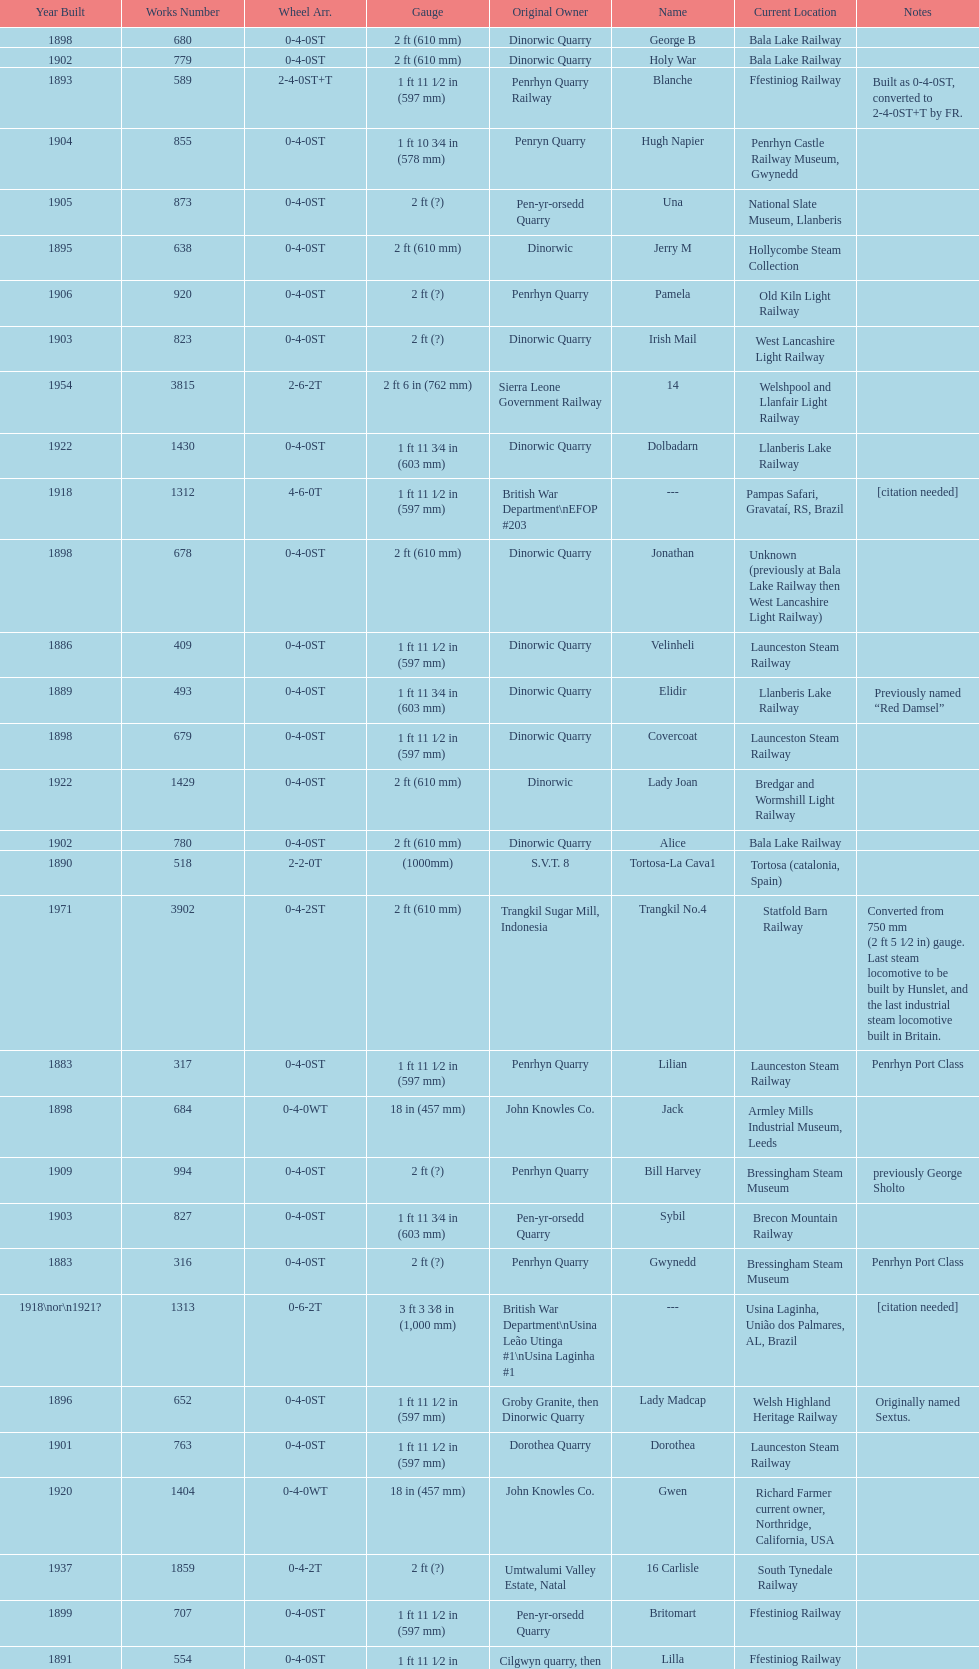What is the difference in gauge between works numbers 541 and 542? 32 mm. Help me parse the entirety of this table. {'header': ['Year Built', 'Works Number', 'Wheel Arr.', 'Gauge', 'Original Owner', 'Name', 'Current Location', 'Notes'], 'rows': [['1898', '680', '0-4-0ST', '2\xa0ft (610\xa0mm)', 'Dinorwic Quarry', 'George B', 'Bala Lake Railway', ''], ['1902', '779', '0-4-0ST', '2\xa0ft (610\xa0mm)', 'Dinorwic Quarry', 'Holy War', 'Bala Lake Railway', ''], ['1893', '589', '2-4-0ST+T', '1\xa0ft 11\xa01⁄2\xa0in (597\xa0mm)', 'Penrhyn Quarry Railway', 'Blanche', 'Ffestiniog Railway', 'Built as 0-4-0ST, converted to 2-4-0ST+T by FR.'], ['1904', '855', '0-4-0ST', '1\xa0ft 10\xa03⁄4\xa0in (578\xa0mm)', 'Penryn Quarry', 'Hugh Napier', 'Penrhyn Castle Railway Museum, Gwynedd', ''], ['1905', '873', '0-4-0ST', '2\xa0ft (?)', 'Pen-yr-orsedd Quarry', 'Una', 'National Slate Museum, Llanberis', ''], ['1895', '638', '0-4-0ST', '2\xa0ft (610\xa0mm)', 'Dinorwic', 'Jerry M', 'Hollycombe Steam Collection', ''], ['1906', '920', '0-4-0ST', '2\xa0ft (?)', 'Penrhyn Quarry', 'Pamela', 'Old Kiln Light Railway', ''], ['1903', '823', '0-4-0ST', '2\xa0ft (?)', 'Dinorwic Quarry', 'Irish Mail', 'West Lancashire Light Railway', ''], ['1954', '3815', '2-6-2T', '2\xa0ft 6\xa0in (762\xa0mm)', 'Sierra Leone Government Railway', '14', 'Welshpool and Llanfair Light Railway', ''], ['1922', '1430', '0-4-0ST', '1\xa0ft 11\xa03⁄4\xa0in (603\xa0mm)', 'Dinorwic Quarry', 'Dolbadarn', 'Llanberis Lake Railway', ''], ['1918', '1312', '4-6-0T', '1\xa0ft\xa011\xa01⁄2\xa0in (597\xa0mm)', 'British War Department\\nEFOP #203', '---', 'Pampas Safari, Gravataí, RS, Brazil', '[citation needed]'], ['1898', '678', '0-4-0ST', '2\xa0ft (610\xa0mm)', 'Dinorwic Quarry', 'Jonathan', 'Unknown (previously at Bala Lake Railway then West Lancashire Light Railway)', ''], ['1886', '409', '0-4-0ST', '1\xa0ft 11\xa01⁄2\xa0in (597\xa0mm)', 'Dinorwic Quarry', 'Velinheli', 'Launceston Steam Railway', ''], ['1889', '493', '0-4-0ST', '1\xa0ft 11\xa03⁄4\xa0in (603\xa0mm)', 'Dinorwic Quarry', 'Elidir', 'Llanberis Lake Railway', 'Previously named “Red Damsel”'], ['1898', '679', '0-4-0ST', '1\xa0ft 11\xa01⁄2\xa0in (597\xa0mm)', 'Dinorwic Quarry', 'Covercoat', 'Launceston Steam Railway', ''], ['1922', '1429', '0-4-0ST', '2\xa0ft (610\xa0mm)', 'Dinorwic', 'Lady Joan', 'Bredgar and Wormshill Light Railway', ''], ['1902', '780', '0-4-0ST', '2\xa0ft (610\xa0mm)', 'Dinorwic Quarry', 'Alice', 'Bala Lake Railway', ''], ['1890', '518', '2-2-0T', '(1000mm)', 'S.V.T. 8', 'Tortosa-La Cava1', 'Tortosa (catalonia, Spain)', ''], ['1971', '3902', '0-4-2ST', '2\xa0ft (610\xa0mm)', 'Trangkil Sugar Mill, Indonesia', 'Trangkil No.4', 'Statfold Barn Railway', 'Converted from 750\xa0mm (2\xa0ft\xa05\xa01⁄2\xa0in) gauge. Last steam locomotive to be built by Hunslet, and the last industrial steam locomotive built in Britain.'], ['1883', '317', '0-4-0ST', '1\xa0ft 11\xa01⁄2\xa0in (597\xa0mm)', 'Penrhyn Quarry', 'Lilian', 'Launceston Steam Railway', 'Penrhyn Port Class'], ['1898', '684', '0-4-0WT', '18\xa0in (457\xa0mm)', 'John Knowles Co.', 'Jack', 'Armley Mills Industrial Museum, Leeds', ''], ['1909', '994', '0-4-0ST', '2\xa0ft (?)', 'Penrhyn Quarry', 'Bill Harvey', 'Bressingham Steam Museum', 'previously George Sholto'], ['1903', '827', '0-4-0ST', '1\xa0ft 11\xa03⁄4\xa0in (603\xa0mm)', 'Pen-yr-orsedd Quarry', 'Sybil', 'Brecon Mountain Railway', ''], ['1883', '316', '0-4-0ST', '2\xa0ft (?)', 'Penrhyn Quarry', 'Gwynedd', 'Bressingham Steam Museum', 'Penrhyn Port Class'], ['1918\\nor\\n1921?', '1313', '0-6-2T', '3\xa0ft\xa03\xa03⁄8\xa0in (1,000\xa0mm)', 'British War Department\\nUsina Leão Utinga #1\\nUsina Laginha #1', '---', 'Usina Laginha, União dos Palmares, AL, Brazil', '[citation needed]'], ['1896', '652', '0-4-0ST', '1\xa0ft 11\xa01⁄2\xa0in (597\xa0mm)', 'Groby Granite, then Dinorwic Quarry', 'Lady Madcap', 'Welsh Highland Heritage Railway', 'Originally named Sextus.'], ['1901', '763', '0-4-0ST', '1\xa0ft 11\xa01⁄2\xa0in (597\xa0mm)', 'Dorothea Quarry', 'Dorothea', 'Launceston Steam Railway', ''], ['1920', '1404', '0-4-0WT', '18\xa0in (457\xa0mm)', 'John Knowles Co.', 'Gwen', 'Richard Farmer current owner, Northridge, California, USA', ''], ['1937', '1859', '0-4-2T', '2\xa0ft (?)', 'Umtwalumi Valley Estate, Natal', '16 Carlisle', 'South Tynedale Railway', ''], ['1899', '707', '0-4-0ST', '1\xa0ft 11\xa01⁄2\xa0in (597\xa0mm)', 'Pen-yr-orsedd Quarry', 'Britomart', 'Ffestiniog Railway', ''], ['1891', '554', '0-4-0ST', '1\xa0ft 11\xa01⁄2\xa0in (597\xa0mm)', 'Cilgwyn quarry, then Penrhyn Quarry Railway', 'Lilla', 'Ffestiniog Railway', ''], ['1882', '283', '0-4-0ST', '1\xa0ft 10\xa03⁄4\xa0in (578\xa0mm)', 'Penrhyn Quarry', 'Charles', 'Penrhyn Castle Railway Museum', ''], ['1903', '822', '0-4-0ST', '2\xa0ft (610\xa0mm)', 'Dinorwic Quarry', 'Maid Marian', 'Bala Lake Railway', ''], ['1893', '590', '2-4-0ST+T', '1\xa0ft 11\xa01⁄2\xa0in (597\xa0mm)', 'Penrhyn Quarry Railway', 'Linda', 'Ffestiniog Railway', 'Built as 0-4-0ST, converted to 2-4-0ST+T by FR.'], ['1902', '783', '0-6-0T', '(1000mm)', 'Sociedad General de Ferrocarriles Vasco-Asturiana', 'VA-21 Nalon', 'Gijon Railway Museum (Spain)', ''], ['1894', '605', '0-4-0ST', '1\xa0ft 11\xa03⁄4\xa0in (603\xa0mm)', 'Penrhyn Quarry', 'Margaret', 'Vale of Rheidol Railway', 'Under restoration.[citation needed]'], ['1940', '2075', '0-4-2T', '2\xa0ft (?)', 'Chaka’s Kraal Sugar Estates, Natal', 'Chaka’s Kraal No. 6', 'North Gloucestershire Railway', ''], ['1885', '364', '0-4-0ST', '22.75', 'Penrhyn Quarry', 'Winifred', 'Bala Lake Railway', 'Penrhyn Port Class'], ['1904', '894', '0-4-0ST', '1\xa0ft 11\xa03⁄4\xa0in (603\xa0mm)', 'Dinorwic Quarry', 'Thomas Bach', 'Llanberis Lake Railway', 'Originally named “Wild Aster”'], ['1891', '541', '0-4-0ST', '1\xa0ft 10\xa03⁄4\xa0in (578\xa0mm)', 'Dinorwic Quarry', 'Rough Pup', 'Narrow Gauge Railway Museum, Tywyn', ''], ['1906', '901', '2-6-2T', '1\xa0ft 11\xa01⁄2\xa0in (597\xa0mm)', 'North Wales Narrow Gauge Railways', 'Russell', 'Welsh Highland Heritage Railway', ''], ['1891', '542', '0-4-0ST', '2\xa0ft (610\xa0mm)', 'Dinorwic Quarry', 'Cloister', 'Purbeck Mineral & Mining Museum', 'Owned by Hampshire Narrow Gauge Railway Trust, previously at Kew Bridge Steam Museum and Amberley'], ['1899', '705', '0-4-0ST', '2\xa0ft (610\xa0mm)', 'Penrhyn Quarry', 'Elin', 'Yaxham Light Railway', 'Previously at the Lincolnshire Coast Light Railway.'], ['1894', '606', '0-4-0ST', '2\xa0ft (?)', 'Penrhyn Quarry', 'Alan George', 'Teifi Valley Railway', '']]} 